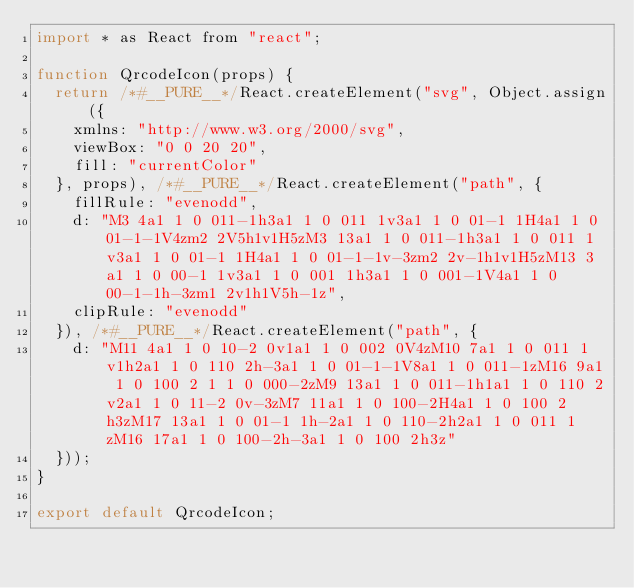Convert code to text. <code><loc_0><loc_0><loc_500><loc_500><_JavaScript_>import * as React from "react";

function QrcodeIcon(props) {
  return /*#__PURE__*/React.createElement("svg", Object.assign({
    xmlns: "http://www.w3.org/2000/svg",
    viewBox: "0 0 20 20",
    fill: "currentColor"
  }, props), /*#__PURE__*/React.createElement("path", {
    fillRule: "evenodd",
    d: "M3 4a1 1 0 011-1h3a1 1 0 011 1v3a1 1 0 01-1 1H4a1 1 0 01-1-1V4zm2 2V5h1v1H5zM3 13a1 1 0 011-1h3a1 1 0 011 1v3a1 1 0 01-1 1H4a1 1 0 01-1-1v-3zm2 2v-1h1v1H5zM13 3a1 1 0 00-1 1v3a1 1 0 001 1h3a1 1 0 001-1V4a1 1 0 00-1-1h-3zm1 2v1h1V5h-1z",
    clipRule: "evenodd"
  }), /*#__PURE__*/React.createElement("path", {
    d: "M11 4a1 1 0 10-2 0v1a1 1 0 002 0V4zM10 7a1 1 0 011 1v1h2a1 1 0 110 2h-3a1 1 0 01-1-1V8a1 1 0 011-1zM16 9a1 1 0 100 2 1 1 0 000-2zM9 13a1 1 0 011-1h1a1 1 0 110 2v2a1 1 0 11-2 0v-3zM7 11a1 1 0 100-2H4a1 1 0 100 2h3zM17 13a1 1 0 01-1 1h-2a1 1 0 110-2h2a1 1 0 011 1zM16 17a1 1 0 100-2h-3a1 1 0 100 2h3z"
  }));
}

export default QrcodeIcon;</code> 